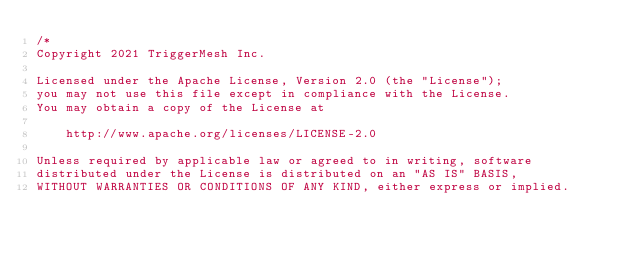<code> <loc_0><loc_0><loc_500><loc_500><_Go_>/*
Copyright 2021 TriggerMesh Inc.

Licensed under the Apache License, Version 2.0 (the "License");
you may not use this file except in compliance with the License.
You may obtain a copy of the License at

    http://www.apache.org/licenses/LICENSE-2.0

Unless required by applicable law or agreed to in writing, software
distributed under the License is distributed on an "AS IS" BASIS,
WITHOUT WARRANTIES OR CONDITIONS OF ANY KIND, either express or implied.</code> 